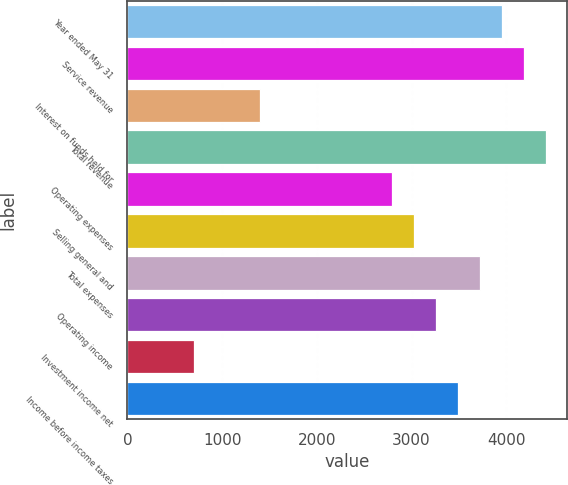Convert chart to OTSL. <chart><loc_0><loc_0><loc_500><loc_500><bar_chart><fcel>Year ended May 31<fcel>Service revenue<fcel>Interest on funds held for<fcel>Total revenue<fcel>Operating expenses<fcel>Selling general and<fcel>Total expenses<fcel>Operating income<fcel>Investment income net<fcel>Income before income taxes<nl><fcel>3953.64<fcel>4186.13<fcel>1396.25<fcel>4418.62<fcel>2791.19<fcel>3023.68<fcel>3721.15<fcel>3256.17<fcel>698.78<fcel>3488.66<nl></chart> 